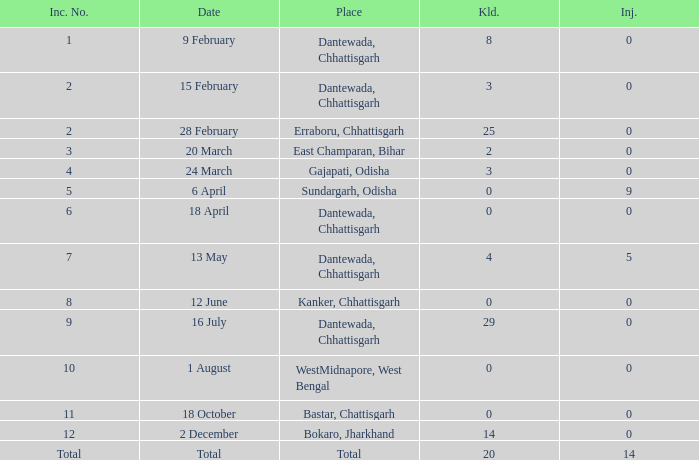What is the least amount of injuries in Dantewada, Chhattisgarh when 8 people were killed? 0.0. 